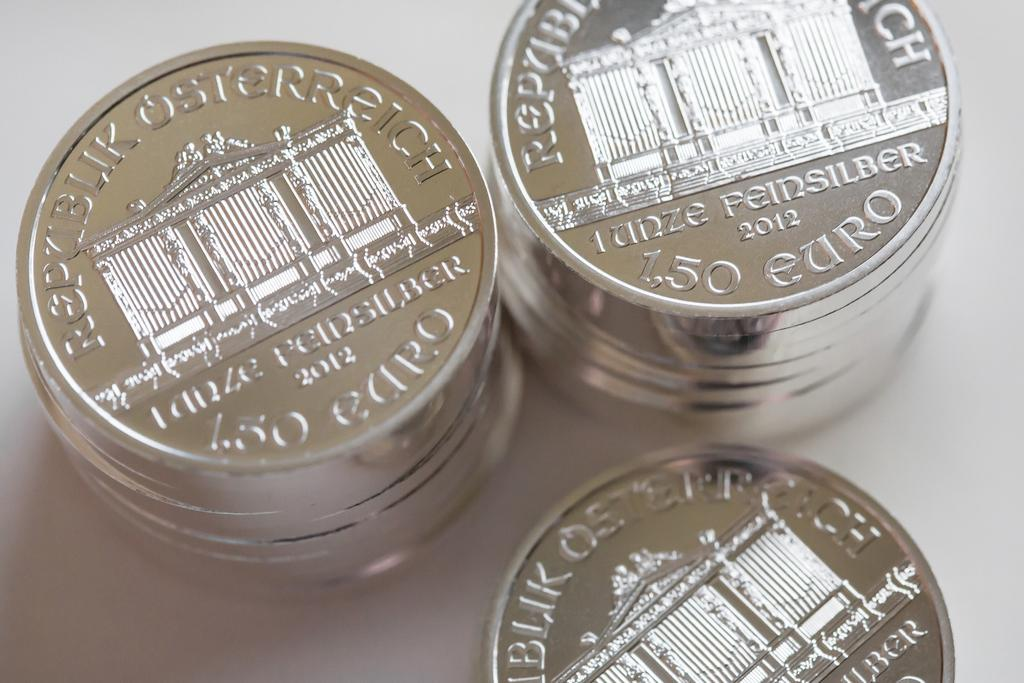<image>
Offer a succinct explanation of the picture presented. Three piles of silver Euros depicting the Brandenburg gate and with a value of 1.50. 